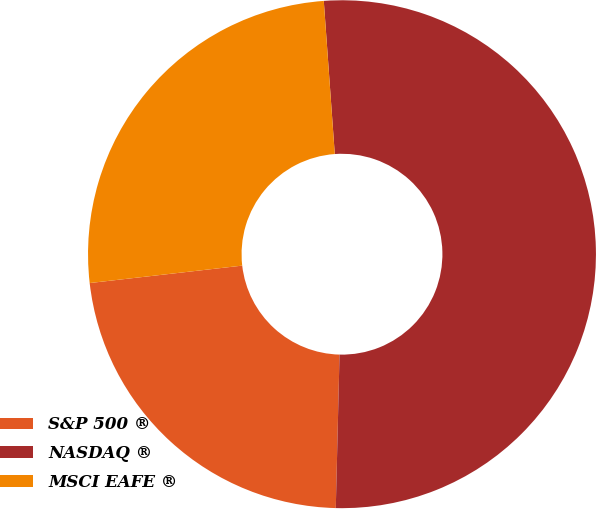Convert chart to OTSL. <chart><loc_0><loc_0><loc_500><loc_500><pie_chart><fcel>S&P 500 ®<fcel>NASDAQ ®<fcel>MSCI EAFE ®<nl><fcel>22.8%<fcel>51.53%<fcel>25.67%<nl></chart> 